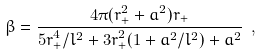Convert formula to latex. <formula><loc_0><loc_0><loc_500><loc_500>\beta = { \frac { 4 \pi ( r _ { + } ^ { 2 } + a ^ { 2 } ) r _ { + } } { 5 r _ { + } ^ { 4 } / l ^ { 2 } + 3 r _ { + } ^ { 2 } ( 1 + a ^ { 2 } / l ^ { 2 } ) + a ^ { 2 } } } \ ,</formula> 